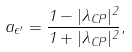<formula> <loc_0><loc_0><loc_500><loc_500>a _ { \epsilon ^ { \prime } } = \frac { 1 - | \lambda _ { C P } | ^ { 2 } } { 1 + | \lambda _ { C P } | ^ { 2 } } ,</formula> 